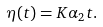Convert formula to latex. <formula><loc_0><loc_0><loc_500><loc_500>\eta ( t ) = K \alpha _ { 2 } t .</formula> 